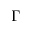Convert formula to latex. <formula><loc_0><loc_0><loc_500><loc_500>\Gamma</formula> 